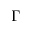Convert formula to latex. <formula><loc_0><loc_0><loc_500><loc_500>\Gamma</formula> 